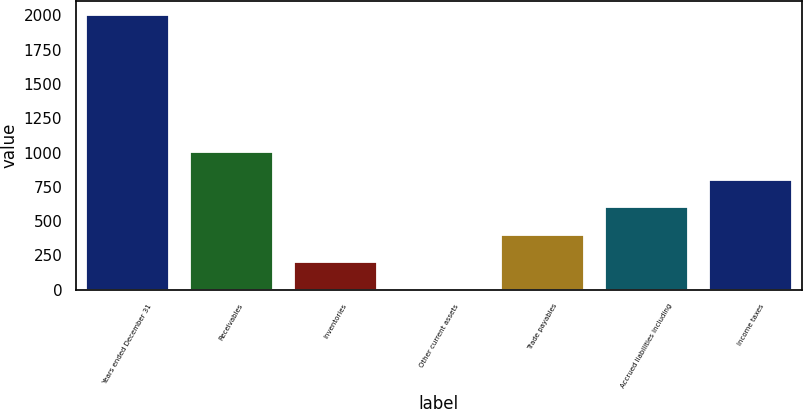<chart> <loc_0><loc_0><loc_500><loc_500><bar_chart><fcel>Years ended December 31<fcel>Receivables<fcel>Inventories<fcel>Other current assets<fcel>Trade payables<fcel>Accrued liabilities including<fcel>Income taxes<nl><fcel>2001<fcel>1000.6<fcel>200.28<fcel>0.2<fcel>400.36<fcel>600.44<fcel>800.52<nl></chart> 